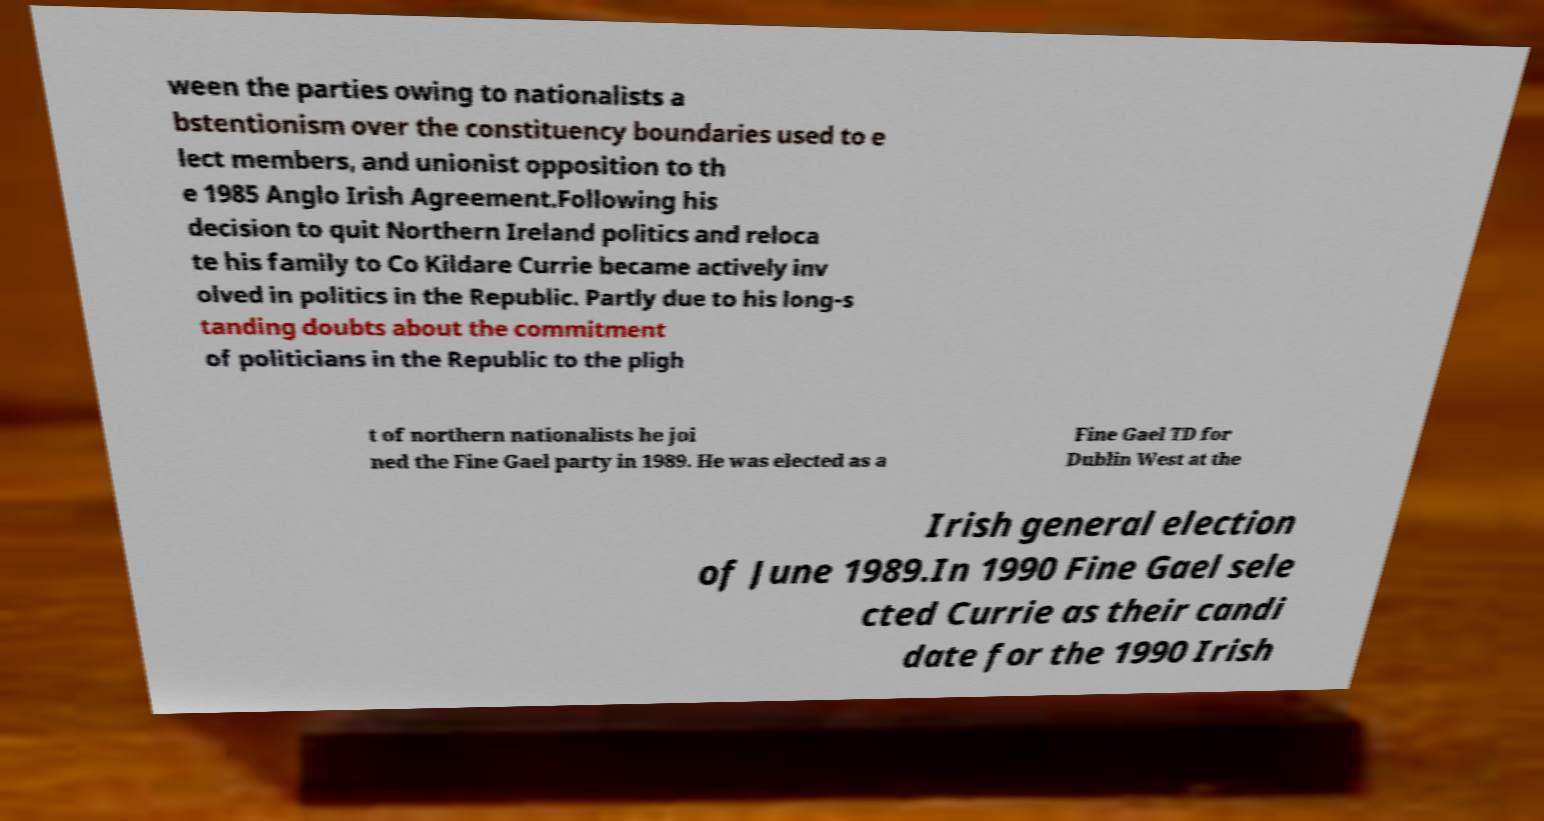Can you read and provide the text displayed in the image?This photo seems to have some interesting text. Can you extract and type it out for me? ween the parties owing to nationalists a bstentionism over the constituency boundaries used to e lect members, and unionist opposition to th e 1985 Anglo Irish Agreement.Following his decision to quit Northern Ireland politics and reloca te his family to Co Kildare Currie became actively inv olved in politics in the Republic. Partly due to his long-s tanding doubts about the commitment of politicians in the Republic to the pligh t of northern nationalists he joi ned the Fine Gael party in 1989. He was elected as a Fine Gael TD for Dublin West at the Irish general election of June 1989.In 1990 Fine Gael sele cted Currie as their candi date for the 1990 Irish 